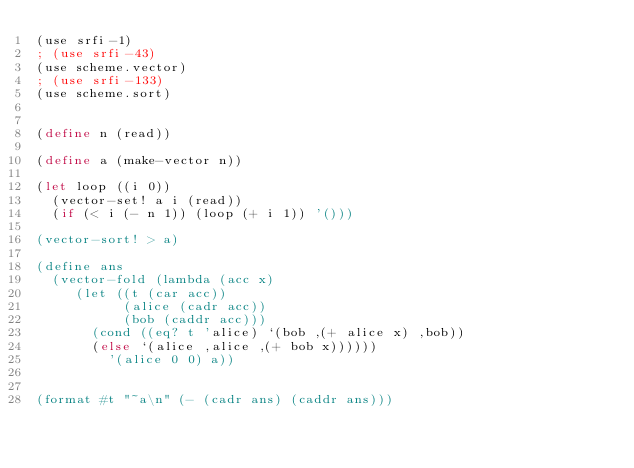Convert code to text. <code><loc_0><loc_0><loc_500><loc_500><_Scheme_>(use srfi-1)
; (use srfi-43)
(use scheme.vector)
; (use srfi-133)
(use scheme.sort)


(define n (read))

(define a (make-vector n))

(let loop ((i 0))
  (vector-set! a i (read))
  (if (< i (- n 1)) (loop (+ i 1)) '()))

(vector-sort! > a)

(define ans
  (vector-fold (lambda (acc x)
		 (let ((t (car acc))
		       (alice (cadr acc))
		       (bob (caddr acc)))
		   (cond ((eq? t 'alice) `(bob ,(+ alice x) ,bob))
			 (else `(alice ,alice ,(+ bob x))))))
	       '(alice 0 0) a))
			  

(format #t "~a\n" (- (cadr ans) (caddr ans)))
</code> 